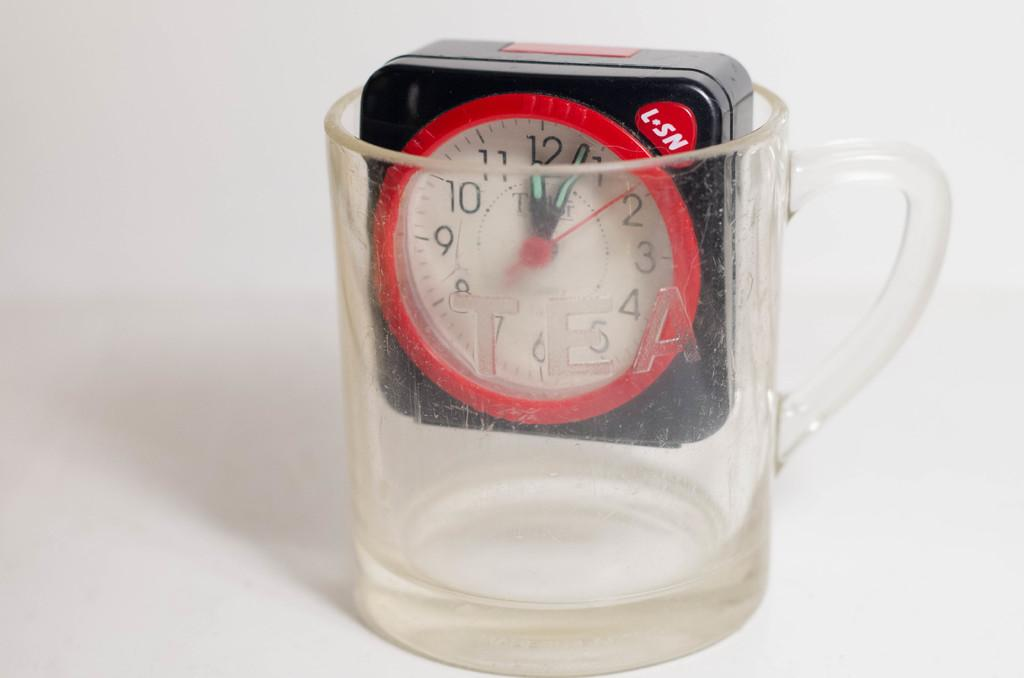<image>
Provide a brief description of the given image. a L-SN clock is sitting inside a clear mug 